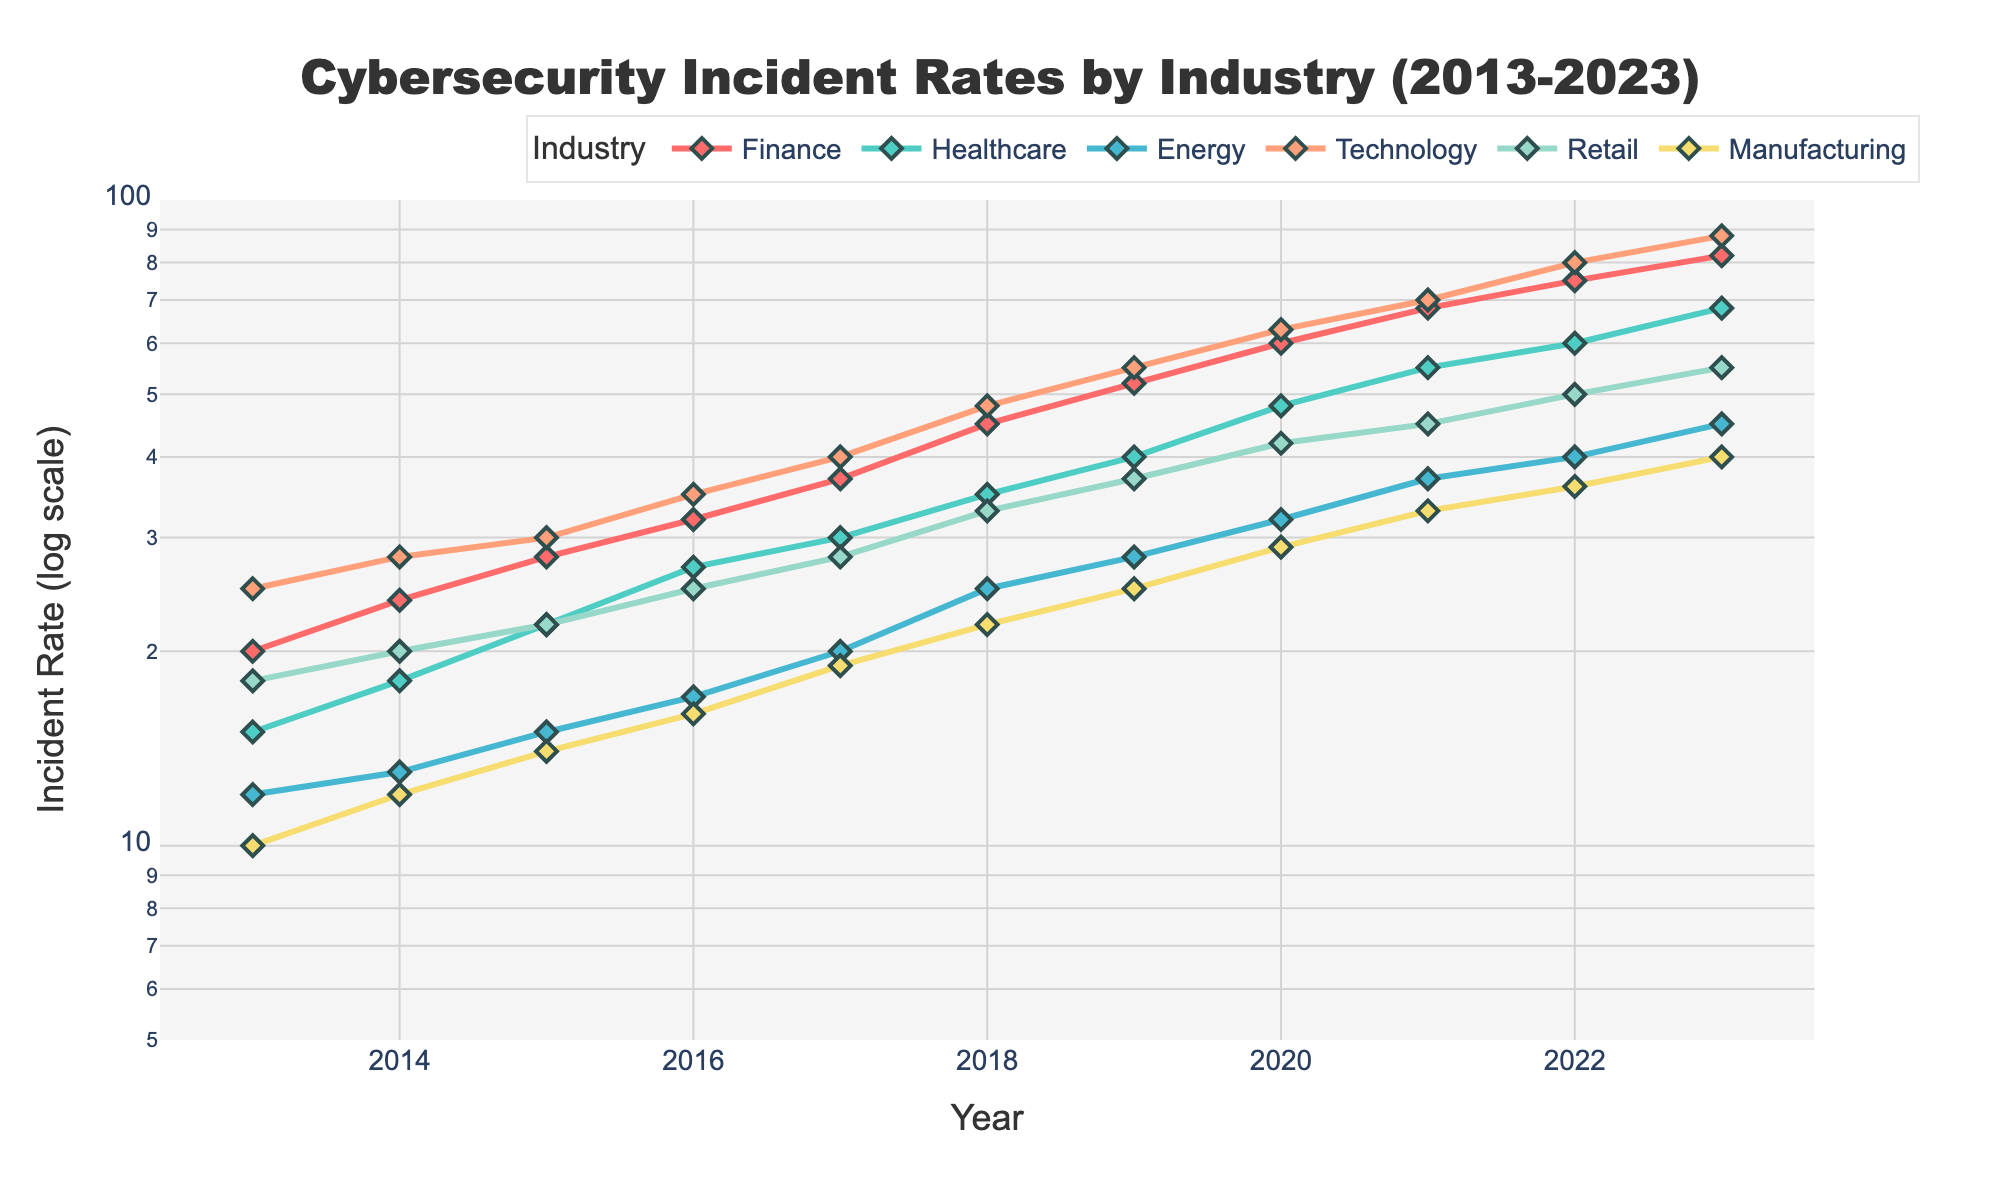What is the title of the plot? The title is located at the top of the figure and reads "Cybersecurity Incident Rates by Industry (2013-2023)"
Answer: Cybersecurity Incident Rates by Industry (2013-2023) How many industries are represented in the plot? The plot contains lines for each represented industry. By counting the lines, colors, and legend entries, we can see six industries: Finance, Healthcare, Energy, Technology, Retail, and Manufacturing.
Answer: Six Which industry had the highest incident rate in 2017? By looking at the y-axis and checking the peak points of each line for 2017, the red line (Finance) reaches the highest point.
Answer: Finance What is the incident rate for the Energy industry in 2021? Locate the year 2021 on the x-axis and follow the corresponding plot line (lighter blue) of the Energy industry. Read the y-axis value, which is 37 (in a log scale equivalent).
Answer: 37 What range does the y-axis cover in this log scale plot? The visual range of the y-axis can be read from its tick marks. The lower bound is 5, and the upper bound is 100, as scaled logarithmically.
Answer: 5 to 100 How has the incident rate for Technology changed from 2013 to 2023? Follow the line representing the Technology industry (orange) from 2013 to 2023. The line shows an upward trend, starting from 25 and ending at 88. Calculate the difference: 88 - 25.
Answer: Increased by 63 Which industry showed the most significant increase in incident rates over the decade? Comparing all industry's endpoint values in 2023 against their starting points in 2013, Finance showed the highest increase (82 - 20 = 62). This requires calculating the change for each: Finance (62), Healthcare (53), Energy (33), Technology (63), Retail (37), Manufacturing (30).
Answer: Technology In which years did the Healthcare industry experience a rate greater than 25 incidents? Check the Healthcare industry line (green) and find where it surpasses the y-axis value of 25. It surpasses this value starting from 2018 onwards (2018-2023).
Answer: 2018-2023 Which industry experienced the smallest total increase in incident rates from 2013 to 2023? Perform the total increase calculation for all industries: Finance (62), Healthcare (53), Energy (33), Technology (63), Retail (37), Manufacturing (30). The smallest increase is in Manufacturing.
Answer: Manufacturing 